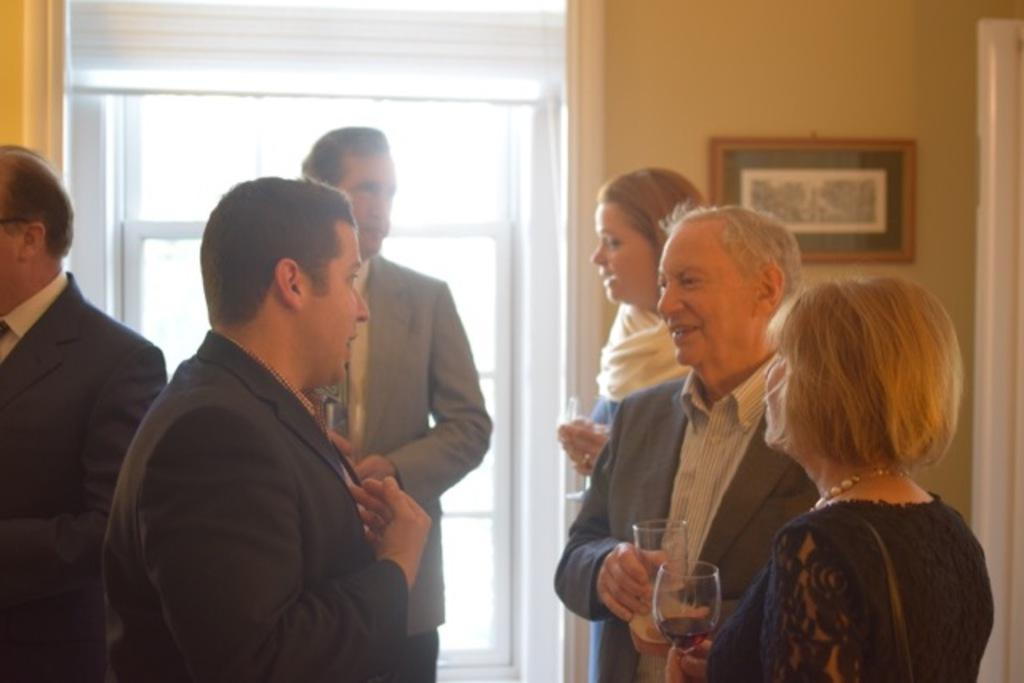What are the people in the image doing? The persons standing in the center of the image are holding glass tumblers. What can be seen in the background of the image? There is a door, a wall, and a photo frame in the background of the image. What type of flower is growing in front of the persons in the image? There are no flowers visible in the image; the persons are holding glass tumblers and standing in front of a door, wall, and photo frame. 